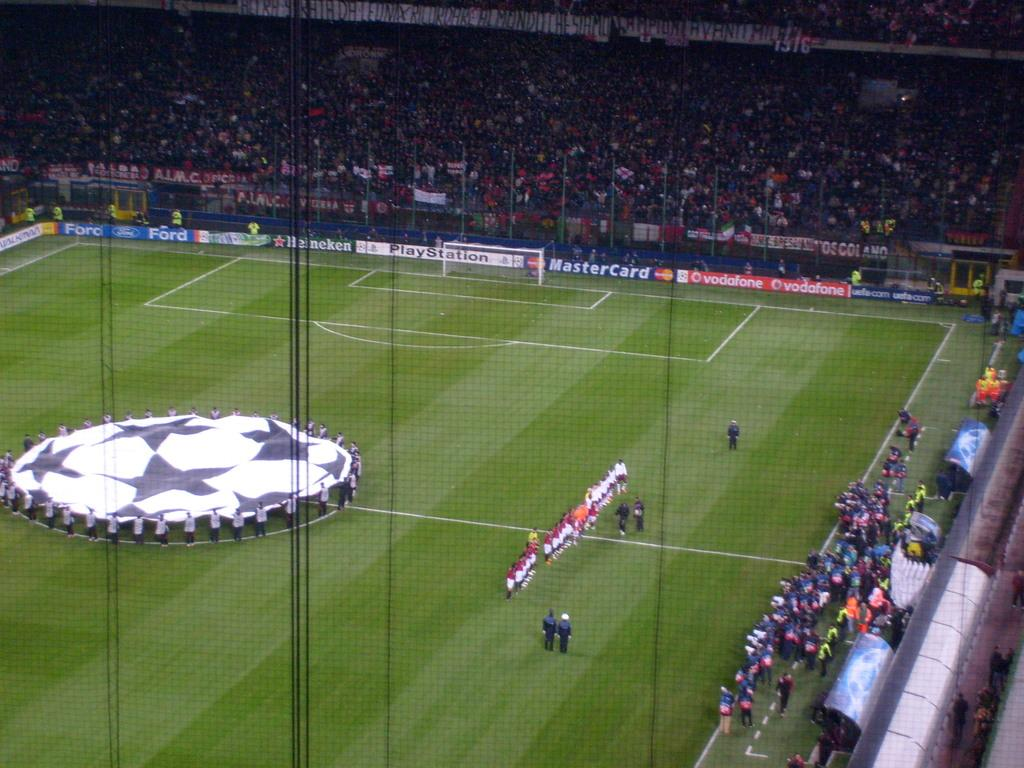<image>
Describe the image concisely. Mastercard advertises at a large soccer stadium that's filled with players and spectators. 